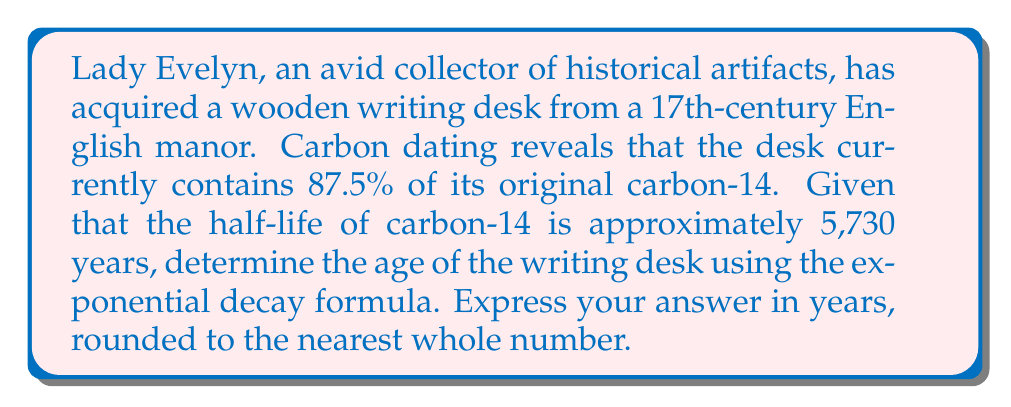Teach me how to tackle this problem. To solve this problem, we'll use the exponential decay formula:

$$A(t) = A_0 \cdot e^{-\lambda t}$$

Where:
$A(t)$ is the amount remaining after time $t$
$A_0$ is the initial amount
$\lambda$ is the decay constant
$t$ is the time elapsed

We know that:
$A(t) = 87.5\%$ of $A_0$, so $A(t) = 0.875A_0$
The half-life $(t_{1/2})$ is 5,730 years

First, we need to calculate the decay constant $\lambda$:

$$\lambda = \frac{\ln(2)}{t_{1/2}} = \frac{\ln(2)}{5730} \approx 1.2097 \times 10^{-4}$$

Now, we can substitute these values into the exponential decay formula:

$$0.875A_0 = A_0 \cdot e^{-\lambda t}$$

Simplifying:

$$0.875 = e^{-\lambda t}$$

Taking the natural logarithm of both sides:

$$\ln(0.875) = -\lambda t$$

Solving for $t$:

$$t = -\frac{\ln(0.875)}{\lambda} = -\frac{\ln(0.875)}{1.2097 \times 10^{-4}} \approx 1105.76$$

Rounding to the nearest whole number, we get 1,106 years.
Answer: 1,106 years 